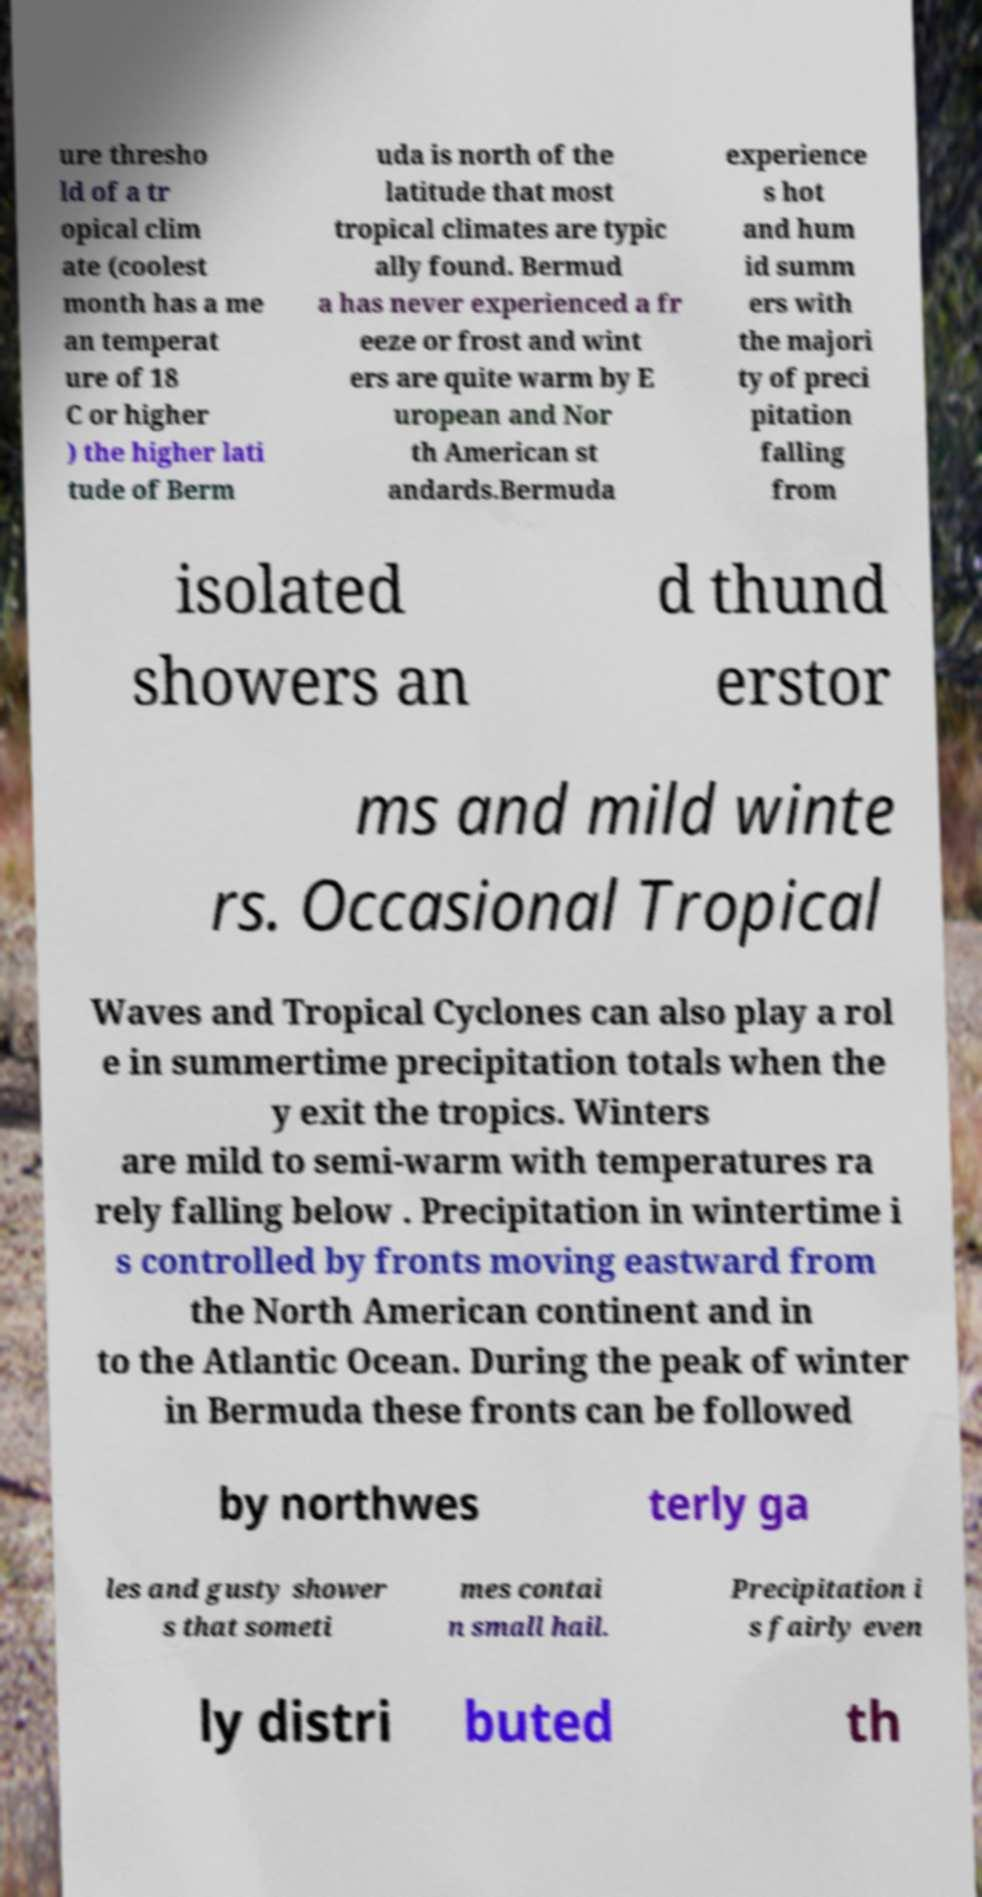Can you accurately transcribe the text from the provided image for me? ure thresho ld of a tr opical clim ate (coolest month has a me an temperat ure of 18 C or higher ) the higher lati tude of Berm uda is north of the latitude that most tropical climates are typic ally found. Bermud a has never experienced a fr eeze or frost and wint ers are quite warm by E uropean and Nor th American st andards.Bermuda experience s hot and hum id summ ers with the majori ty of preci pitation falling from isolated showers an d thund erstor ms and mild winte rs. Occasional Tropical Waves and Tropical Cyclones can also play a rol e in summertime precipitation totals when the y exit the tropics. Winters are mild to semi-warm with temperatures ra rely falling below . Precipitation in wintertime i s controlled by fronts moving eastward from the North American continent and in to the Atlantic Ocean. During the peak of winter in Bermuda these fronts can be followed by northwes terly ga les and gusty shower s that someti mes contai n small hail. Precipitation i s fairly even ly distri buted th 